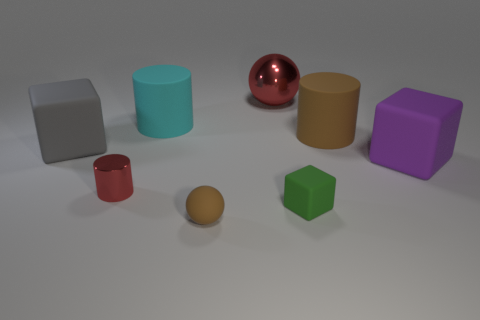Can you tell me the number of objects on the table that are not cubes? There are five objects on the table that are not cubes. These include two cylindrical objects, two cups, and a sphere. 